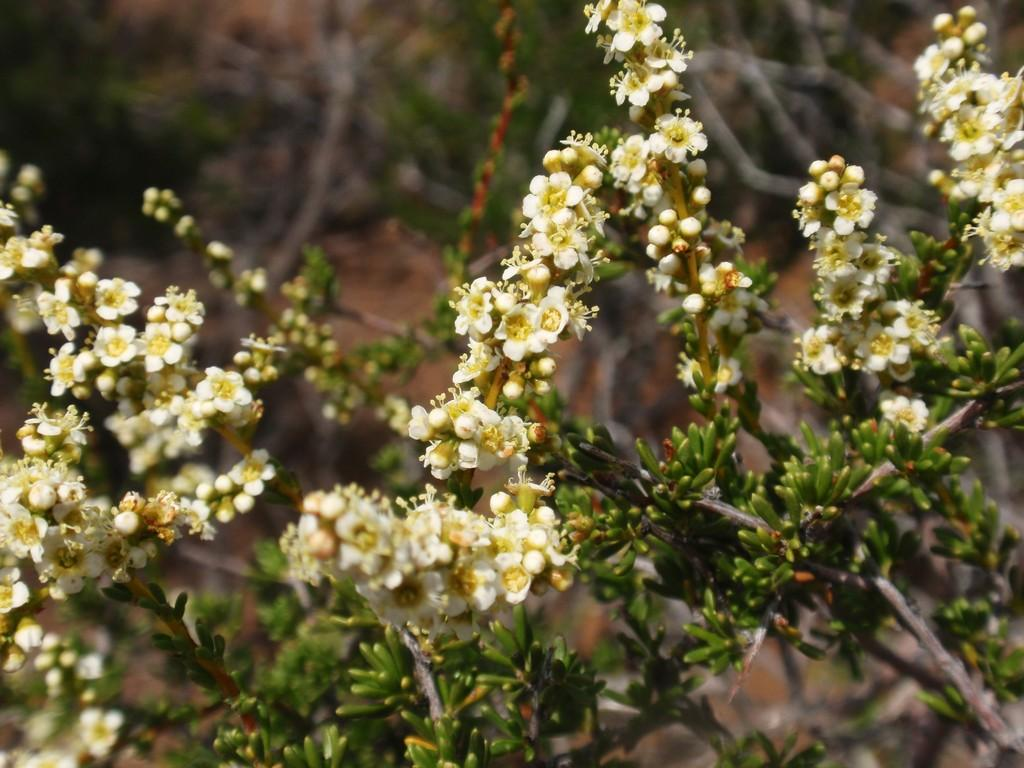What type of living organisms can be seen in the image? Plants can be seen in the image. What additional feature can be observed on the plants? The plants have flowers on them. What type of cactus can be seen in the image? There is no cactus present in the image; the plants in the image have flowers on them. What is the maid doing in the image? There is no maid present in the image; it only features plants with flowers. 